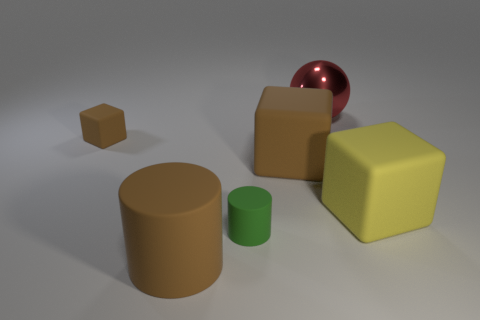Subtract all gray blocks. Subtract all blue cylinders. How many blocks are left? 3 Add 4 big matte cubes. How many objects exist? 10 Subtract all cylinders. How many objects are left? 4 Add 5 brown things. How many brown things are left? 8 Add 4 rubber cubes. How many rubber cubes exist? 7 Subtract 0 red cubes. How many objects are left? 6 Subtract all small rubber cylinders. Subtract all small purple rubber blocks. How many objects are left? 5 